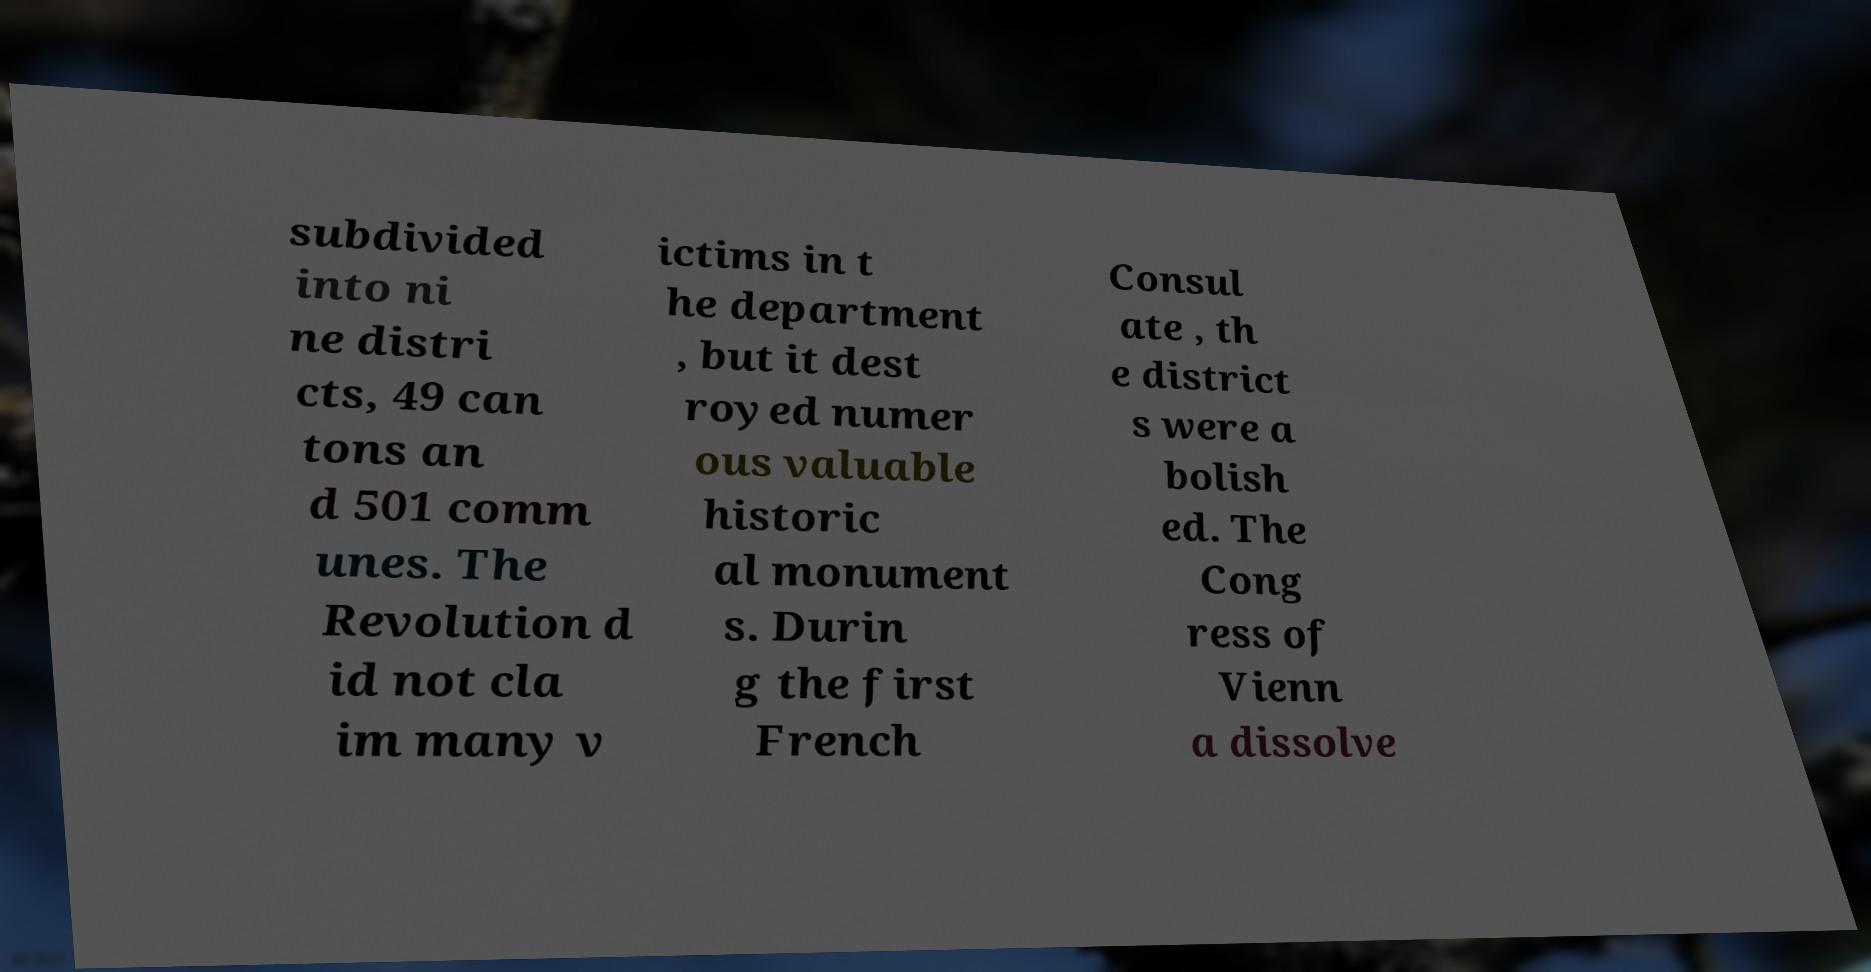Please read and relay the text visible in this image. What does it say? subdivided into ni ne distri cts, 49 can tons an d 501 comm unes. The Revolution d id not cla im many v ictims in t he department , but it dest royed numer ous valuable historic al monument s. Durin g the first French Consul ate , th e district s were a bolish ed. The Cong ress of Vienn a dissolve 